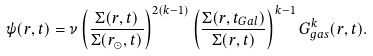Convert formula to latex. <formula><loc_0><loc_0><loc_500><loc_500>\psi ( r , t ) = \nu \left ( \frac { \Sigma ( r , t ) } { \Sigma ( r _ { \odot } , t ) } \right ) ^ { 2 ( k - 1 ) } \left ( \frac { \Sigma ( r , t _ { G a l } ) } { \Sigma ( r , t ) } \right ) ^ { k - 1 } G ^ { k } _ { g a s } ( r , t ) .</formula> 